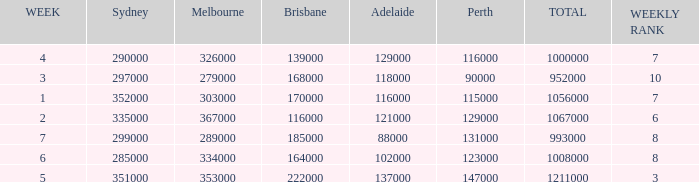How many Adelaide viewers were there in Week 5? 137000.0. 